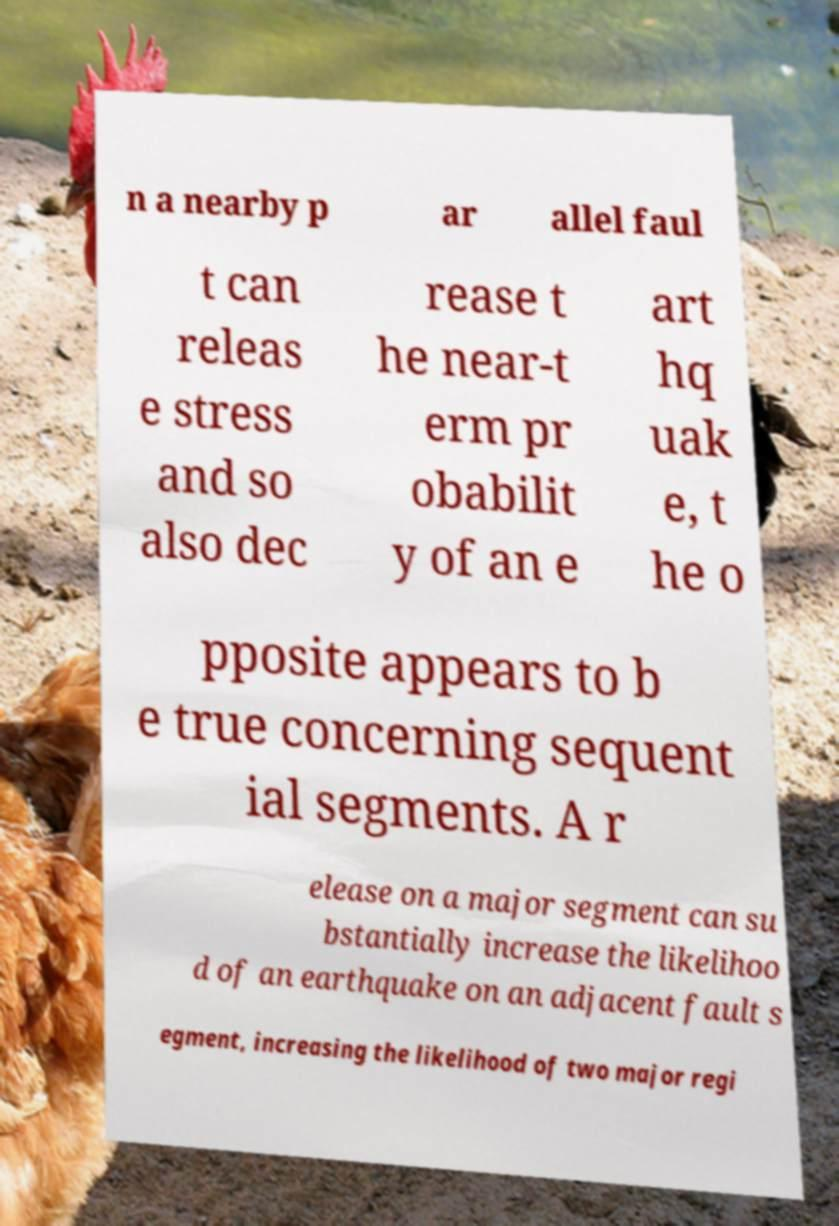Please read and relay the text visible in this image. What does it say? n a nearby p ar allel faul t can releas e stress and so also dec rease t he near-t erm pr obabilit y of an e art hq uak e, t he o pposite appears to b e true concerning sequent ial segments. A r elease on a major segment can su bstantially increase the likelihoo d of an earthquake on an adjacent fault s egment, increasing the likelihood of two major regi 